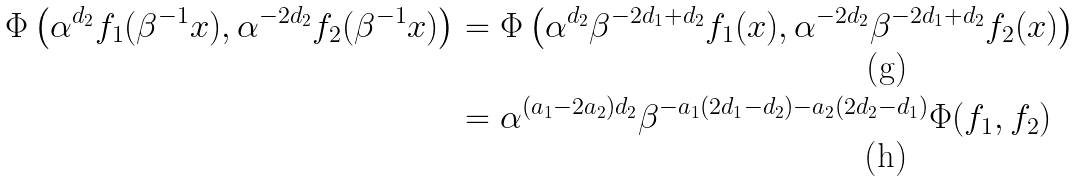Convert formula to latex. <formula><loc_0><loc_0><loc_500><loc_500>\Phi \left ( \alpha ^ { d _ { 2 } } f _ { 1 } ( \beta ^ { - 1 } x ) , \alpha ^ { - 2 d _ { 2 } } f _ { 2 } ( \beta ^ { - 1 } x ) \right ) & = \Phi \left ( \alpha ^ { d _ { 2 } } \beta ^ { - 2 d _ { 1 } + d _ { 2 } } f _ { 1 } ( x ) , \alpha ^ { - 2 d _ { 2 } } \beta ^ { - 2 d _ { 1 } + d _ { 2 } } f _ { 2 } ( x ) \right ) \\ & = \alpha ^ { ( a _ { 1 } - 2 a _ { 2 } ) d _ { 2 } } \beta ^ { - a _ { 1 } ( 2 d _ { 1 } - d _ { 2 } ) - a _ { 2 } ( 2 d _ { 2 } - d _ { 1 } ) } \Phi ( f _ { 1 } , f _ { 2 } )</formula> 